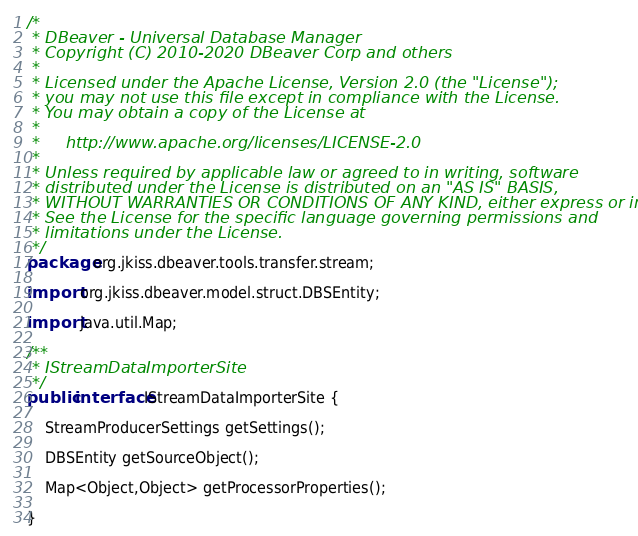<code> <loc_0><loc_0><loc_500><loc_500><_Java_>/*
 * DBeaver - Universal Database Manager
 * Copyright (C) 2010-2020 DBeaver Corp and others
 *
 * Licensed under the Apache License, Version 2.0 (the "License");
 * you may not use this file except in compliance with the License.
 * You may obtain a copy of the License at
 *
 *     http://www.apache.org/licenses/LICENSE-2.0
 *
 * Unless required by applicable law or agreed to in writing, software
 * distributed under the License is distributed on an "AS IS" BASIS,
 * WITHOUT WARRANTIES OR CONDITIONS OF ANY KIND, either express or implied.
 * See the License for the specific language governing permissions and
 * limitations under the License.
 */
package org.jkiss.dbeaver.tools.transfer.stream;

import org.jkiss.dbeaver.model.struct.DBSEntity;

import java.util.Map;

/**
 * IStreamDataImporterSite
 */
public interface IStreamDataImporterSite {

    StreamProducerSettings getSettings();

    DBSEntity getSourceObject();

    Map<Object,Object> getProcessorProperties();

}</code> 